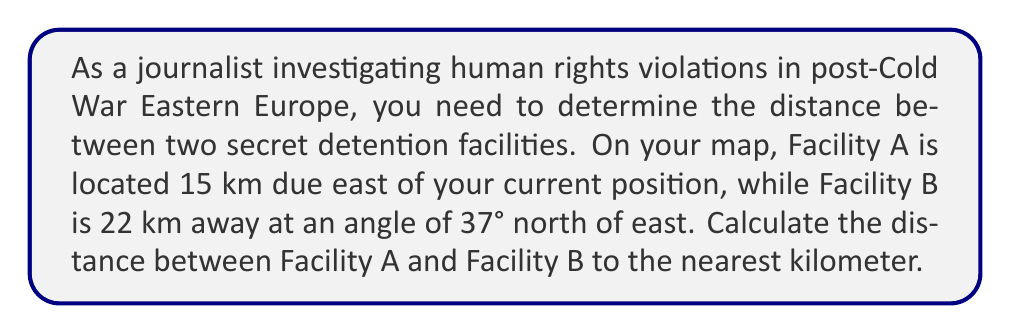Show me your answer to this math problem. To solve this problem, we can use the law of cosines, as we have a triangle with two known sides and the angle between them.

1. Let's define our triangle:
   - Side a: distance from your position to Facility B (22 km)
   - Side b: distance from your position to Facility A (15 km)
   - Angle C: 37° (the angle between the two facilities from your position)

2. The law of cosines states:
   $$ c^2 = a^2 + b^2 - 2ab \cos(C) $$
   Where c is the distance we're trying to find between Facility A and Facility B.

3. Let's plug in our known values:
   $$ c^2 = 22^2 + 15^2 - 2(22)(15) \cos(37°) $$

4. Simplify:
   $$ c^2 = 484 + 225 - 660 \cos(37°) $$

5. Calculate $\cos(37°)$ ≈ 0.7986

6. Substitute and calculate:
   $$ c^2 = 484 + 225 - 660(0.7986) $$
   $$ c^2 = 484 + 225 - 527.076 $$
   $$ c^2 = 181.924 $$

7. Take the square root of both sides:
   $$ c = \sqrt{181.924} ≈ 13.49 $$

8. Round to the nearest kilometer:
   $$ c ≈ 13 \text{ km} $$
Answer: 13 km 